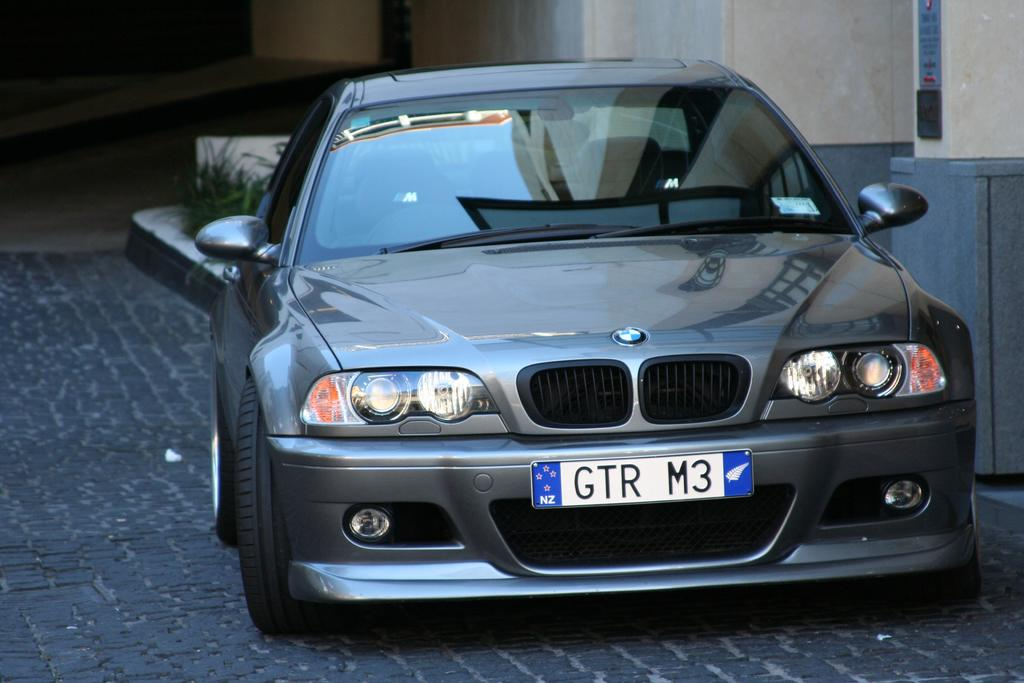What type of vehicle is in the image? There is a grey color car in the image. Where is the car located in relation to other objects? The car is parked near a wall. What can be seen in the background of the image? There is a building in the background of the image. What type of vegetation is on the left side of the image? There are plants on the left side of the image. What type of dress is hanging on the wall next to the car? There is no dress present in the image; it only features a grey color car parked near a wall, plants on the left side, and a building in the background. 